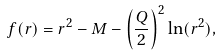Convert formula to latex. <formula><loc_0><loc_0><loc_500><loc_500>f ( r ) = r ^ { 2 } - M - \left ( \frac { Q } { 2 } \right ) ^ { 2 } \ln ( r ^ { 2 } ) ,</formula> 